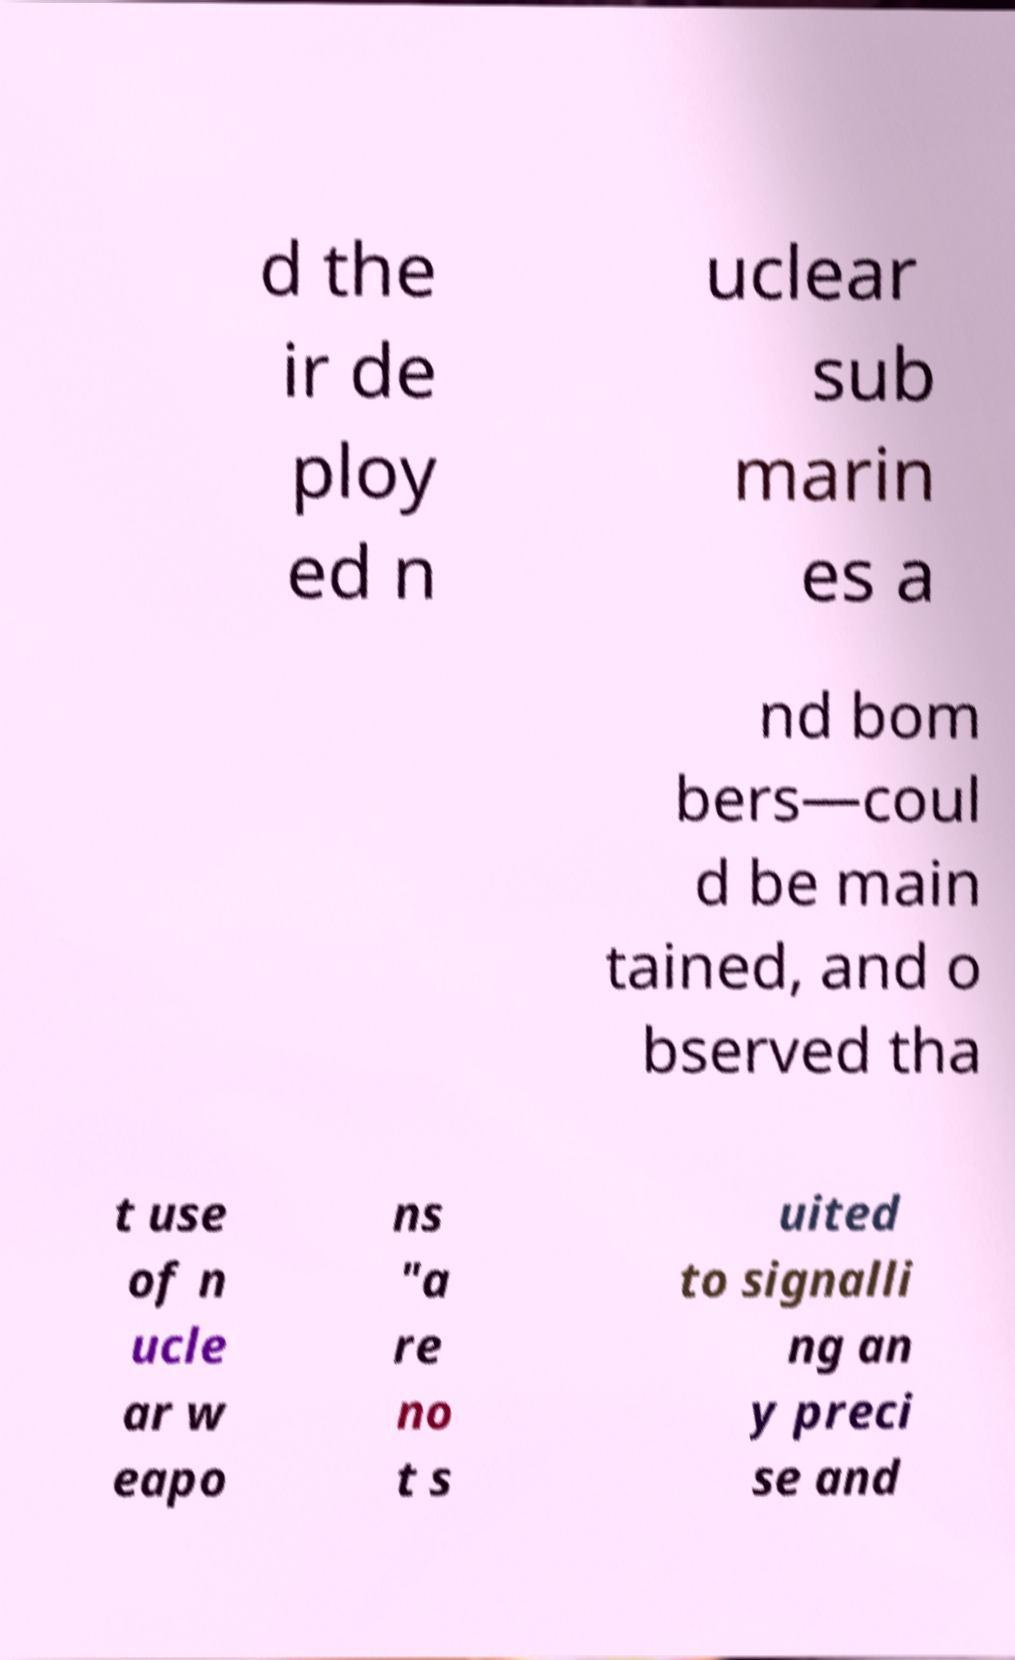For documentation purposes, I need the text within this image transcribed. Could you provide that? d the ir de ploy ed n uclear sub marin es a nd bom bers—coul d be main tained, and o bserved tha t use of n ucle ar w eapo ns "a re no t s uited to signalli ng an y preci se and 